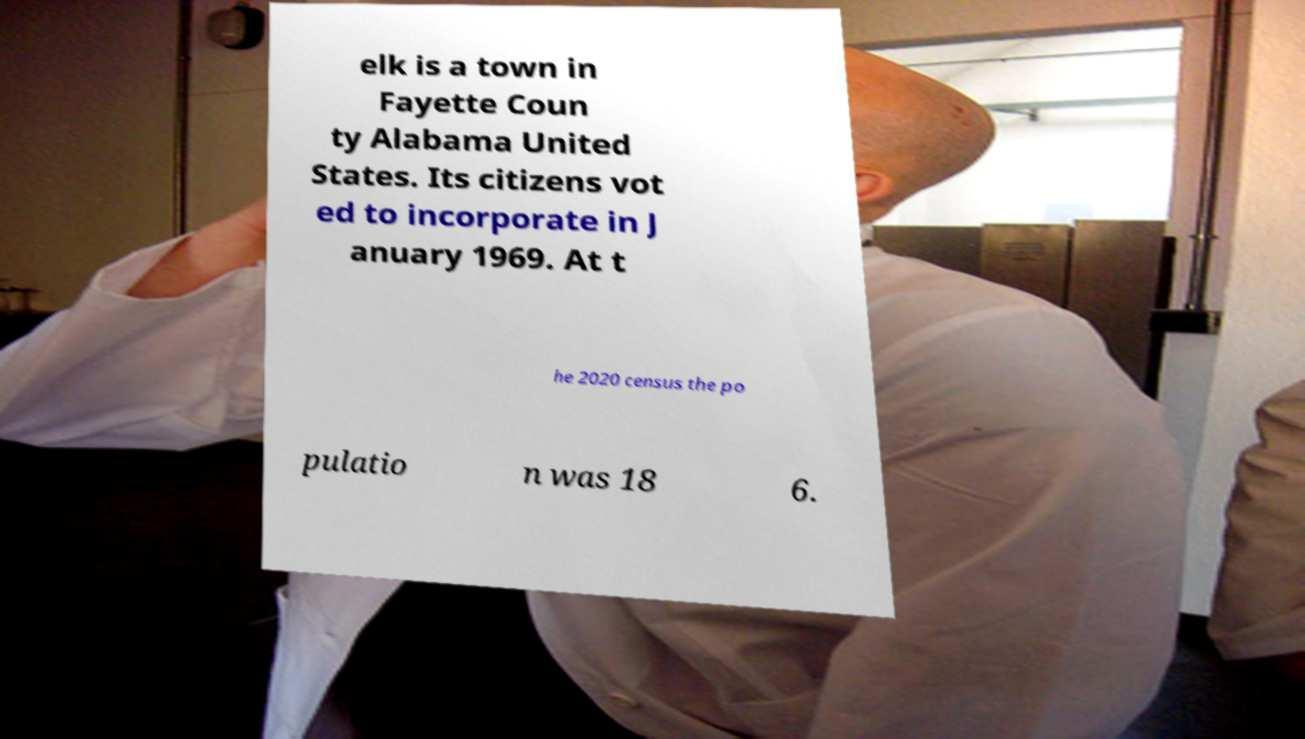I need the written content from this picture converted into text. Can you do that? elk is a town in Fayette Coun ty Alabama United States. Its citizens vot ed to incorporate in J anuary 1969. At t he 2020 census the po pulatio n was 18 6. 